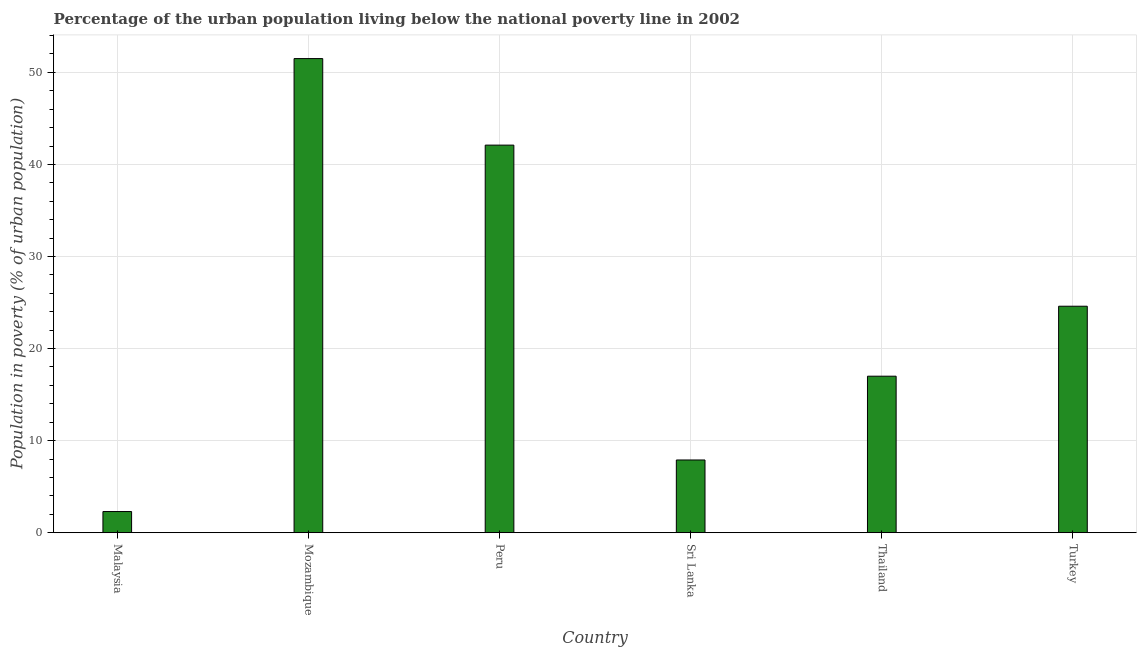Does the graph contain any zero values?
Your response must be concise. No. Does the graph contain grids?
Provide a short and direct response. Yes. What is the title of the graph?
Give a very brief answer. Percentage of the urban population living below the national poverty line in 2002. What is the label or title of the Y-axis?
Provide a succinct answer. Population in poverty (% of urban population). What is the percentage of urban population living below poverty line in Thailand?
Give a very brief answer. 17. Across all countries, what is the maximum percentage of urban population living below poverty line?
Keep it short and to the point. 51.5. Across all countries, what is the minimum percentage of urban population living below poverty line?
Give a very brief answer. 2.3. In which country was the percentage of urban population living below poverty line maximum?
Provide a succinct answer. Mozambique. In which country was the percentage of urban population living below poverty line minimum?
Provide a succinct answer. Malaysia. What is the sum of the percentage of urban population living below poverty line?
Offer a terse response. 145.4. What is the difference between the percentage of urban population living below poverty line in Malaysia and Sri Lanka?
Your answer should be very brief. -5.6. What is the average percentage of urban population living below poverty line per country?
Keep it short and to the point. 24.23. What is the median percentage of urban population living below poverty line?
Ensure brevity in your answer.  20.8. In how many countries, is the percentage of urban population living below poverty line greater than 24 %?
Provide a short and direct response. 3. What is the ratio of the percentage of urban population living below poverty line in Mozambique to that in Sri Lanka?
Offer a very short reply. 6.52. Is the percentage of urban population living below poverty line in Thailand less than that in Turkey?
Provide a short and direct response. Yes. What is the difference between the highest and the second highest percentage of urban population living below poverty line?
Ensure brevity in your answer.  9.4. What is the difference between the highest and the lowest percentage of urban population living below poverty line?
Provide a succinct answer. 49.2. In how many countries, is the percentage of urban population living below poverty line greater than the average percentage of urban population living below poverty line taken over all countries?
Offer a very short reply. 3. How many bars are there?
Offer a terse response. 6. How many countries are there in the graph?
Ensure brevity in your answer.  6. Are the values on the major ticks of Y-axis written in scientific E-notation?
Your answer should be compact. No. What is the Population in poverty (% of urban population) of Mozambique?
Make the answer very short. 51.5. What is the Population in poverty (% of urban population) in Peru?
Your answer should be compact. 42.1. What is the Population in poverty (% of urban population) in Sri Lanka?
Provide a succinct answer. 7.9. What is the Population in poverty (% of urban population) of Turkey?
Give a very brief answer. 24.6. What is the difference between the Population in poverty (% of urban population) in Malaysia and Mozambique?
Keep it short and to the point. -49.2. What is the difference between the Population in poverty (% of urban population) in Malaysia and Peru?
Make the answer very short. -39.8. What is the difference between the Population in poverty (% of urban population) in Malaysia and Thailand?
Ensure brevity in your answer.  -14.7. What is the difference between the Population in poverty (% of urban population) in Malaysia and Turkey?
Ensure brevity in your answer.  -22.3. What is the difference between the Population in poverty (% of urban population) in Mozambique and Peru?
Offer a terse response. 9.4. What is the difference between the Population in poverty (% of urban population) in Mozambique and Sri Lanka?
Keep it short and to the point. 43.6. What is the difference between the Population in poverty (% of urban population) in Mozambique and Thailand?
Offer a very short reply. 34.5. What is the difference between the Population in poverty (% of urban population) in Mozambique and Turkey?
Offer a very short reply. 26.9. What is the difference between the Population in poverty (% of urban population) in Peru and Sri Lanka?
Give a very brief answer. 34.2. What is the difference between the Population in poverty (% of urban population) in Peru and Thailand?
Keep it short and to the point. 25.1. What is the difference between the Population in poverty (% of urban population) in Peru and Turkey?
Your answer should be compact. 17.5. What is the difference between the Population in poverty (% of urban population) in Sri Lanka and Thailand?
Your answer should be very brief. -9.1. What is the difference between the Population in poverty (% of urban population) in Sri Lanka and Turkey?
Make the answer very short. -16.7. What is the difference between the Population in poverty (% of urban population) in Thailand and Turkey?
Your response must be concise. -7.6. What is the ratio of the Population in poverty (% of urban population) in Malaysia to that in Mozambique?
Ensure brevity in your answer.  0.04. What is the ratio of the Population in poverty (% of urban population) in Malaysia to that in Peru?
Offer a terse response. 0.06. What is the ratio of the Population in poverty (% of urban population) in Malaysia to that in Sri Lanka?
Your response must be concise. 0.29. What is the ratio of the Population in poverty (% of urban population) in Malaysia to that in Thailand?
Provide a short and direct response. 0.14. What is the ratio of the Population in poverty (% of urban population) in Malaysia to that in Turkey?
Your answer should be compact. 0.09. What is the ratio of the Population in poverty (% of urban population) in Mozambique to that in Peru?
Ensure brevity in your answer.  1.22. What is the ratio of the Population in poverty (% of urban population) in Mozambique to that in Sri Lanka?
Your response must be concise. 6.52. What is the ratio of the Population in poverty (% of urban population) in Mozambique to that in Thailand?
Your response must be concise. 3.03. What is the ratio of the Population in poverty (% of urban population) in Mozambique to that in Turkey?
Your answer should be compact. 2.09. What is the ratio of the Population in poverty (% of urban population) in Peru to that in Sri Lanka?
Offer a terse response. 5.33. What is the ratio of the Population in poverty (% of urban population) in Peru to that in Thailand?
Provide a short and direct response. 2.48. What is the ratio of the Population in poverty (% of urban population) in Peru to that in Turkey?
Your answer should be very brief. 1.71. What is the ratio of the Population in poverty (% of urban population) in Sri Lanka to that in Thailand?
Provide a succinct answer. 0.47. What is the ratio of the Population in poverty (% of urban population) in Sri Lanka to that in Turkey?
Your response must be concise. 0.32. What is the ratio of the Population in poverty (% of urban population) in Thailand to that in Turkey?
Give a very brief answer. 0.69. 